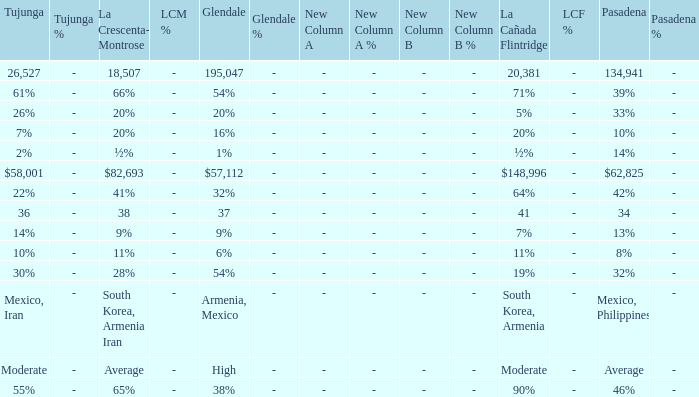What is the percentage of Glendale when La Canada Flintridge is 5%? 20%. 